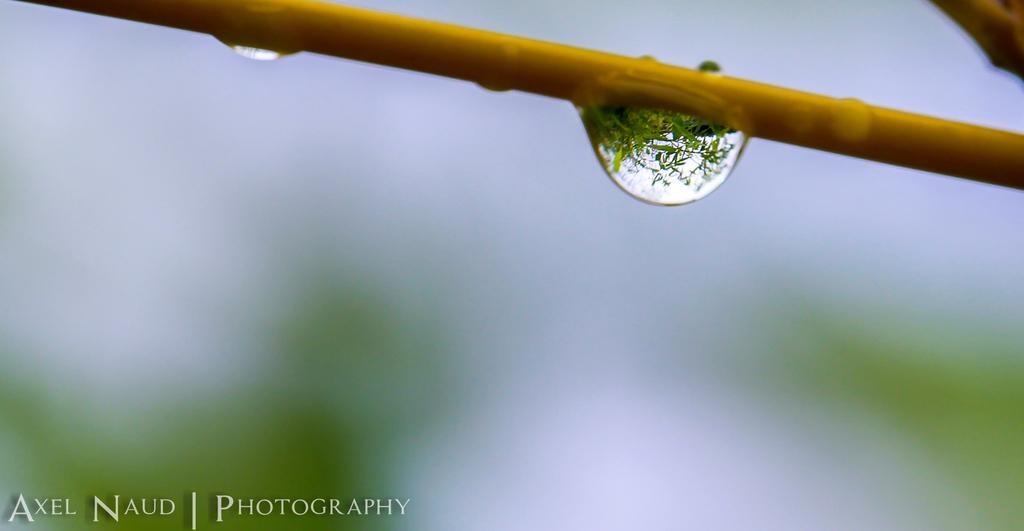What is the main subject of the image? The main subject of the image is a branch of a plant. What can be observed on the branch? There are water droplets on the branch. How would you describe the background of the image? The background of the image is blurry. Is there any text present in the image? Yes, there is some text visible at the bottom of the image. How many crates are being transported in the image? There are no crates or any form of transportation present in the image. What color is the crate in the image? There is no crate in the image, so it is impossible to determine its color. 